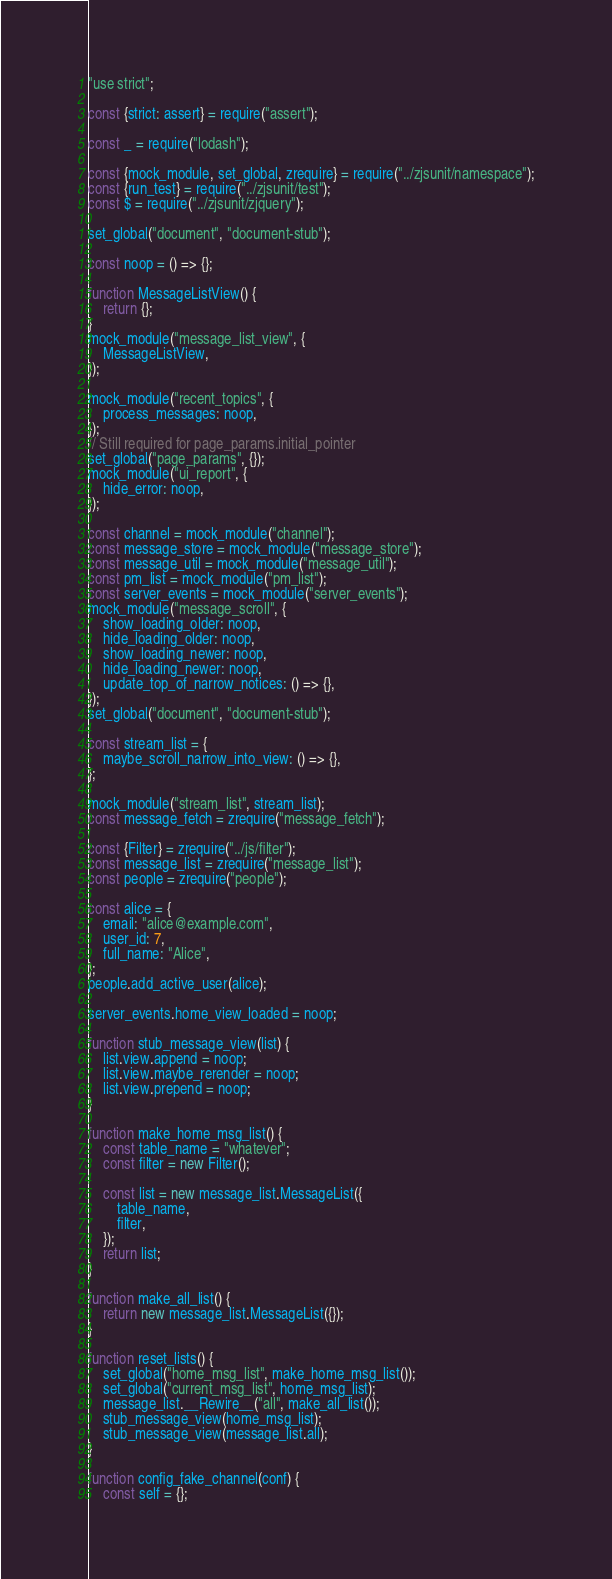<code> <loc_0><loc_0><loc_500><loc_500><_JavaScript_>"use strict";

const {strict: assert} = require("assert");

const _ = require("lodash");

const {mock_module, set_global, zrequire} = require("../zjsunit/namespace");
const {run_test} = require("../zjsunit/test");
const $ = require("../zjsunit/zjquery");

set_global("document", "document-stub");

const noop = () => {};

function MessageListView() {
    return {};
}
mock_module("message_list_view", {
    MessageListView,
});

mock_module("recent_topics", {
    process_messages: noop,
});
// Still required for page_params.initial_pointer
set_global("page_params", {});
mock_module("ui_report", {
    hide_error: noop,
});

const channel = mock_module("channel");
const message_store = mock_module("message_store");
const message_util = mock_module("message_util");
const pm_list = mock_module("pm_list");
const server_events = mock_module("server_events");
mock_module("message_scroll", {
    show_loading_older: noop,
    hide_loading_older: noop,
    show_loading_newer: noop,
    hide_loading_newer: noop,
    update_top_of_narrow_notices: () => {},
});
set_global("document", "document-stub");

const stream_list = {
    maybe_scroll_narrow_into_view: () => {},
};

mock_module("stream_list", stream_list);
const message_fetch = zrequire("message_fetch");

const {Filter} = zrequire("../js/filter");
const message_list = zrequire("message_list");
const people = zrequire("people");

const alice = {
    email: "alice@example.com",
    user_id: 7,
    full_name: "Alice",
};
people.add_active_user(alice);

server_events.home_view_loaded = noop;

function stub_message_view(list) {
    list.view.append = noop;
    list.view.maybe_rerender = noop;
    list.view.prepend = noop;
}

function make_home_msg_list() {
    const table_name = "whatever";
    const filter = new Filter();

    const list = new message_list.MessageList({
        table_name,
        filter,
    });
    return list;
}

function make_all_list() {
    return new message_list.MessageList({});
}

function reset_lists() {
    set_global("home_msg_list", make_home_msg_list());
    set_global("current_msg_list", home_msg_list);
    message_list.__Rewire__("all", make_all_list());
    stub_message_view(home_msg_list);
    stub_message_view(message_list.all);
}

function config_fake_channel(conf) {
    const self = {};</code> 